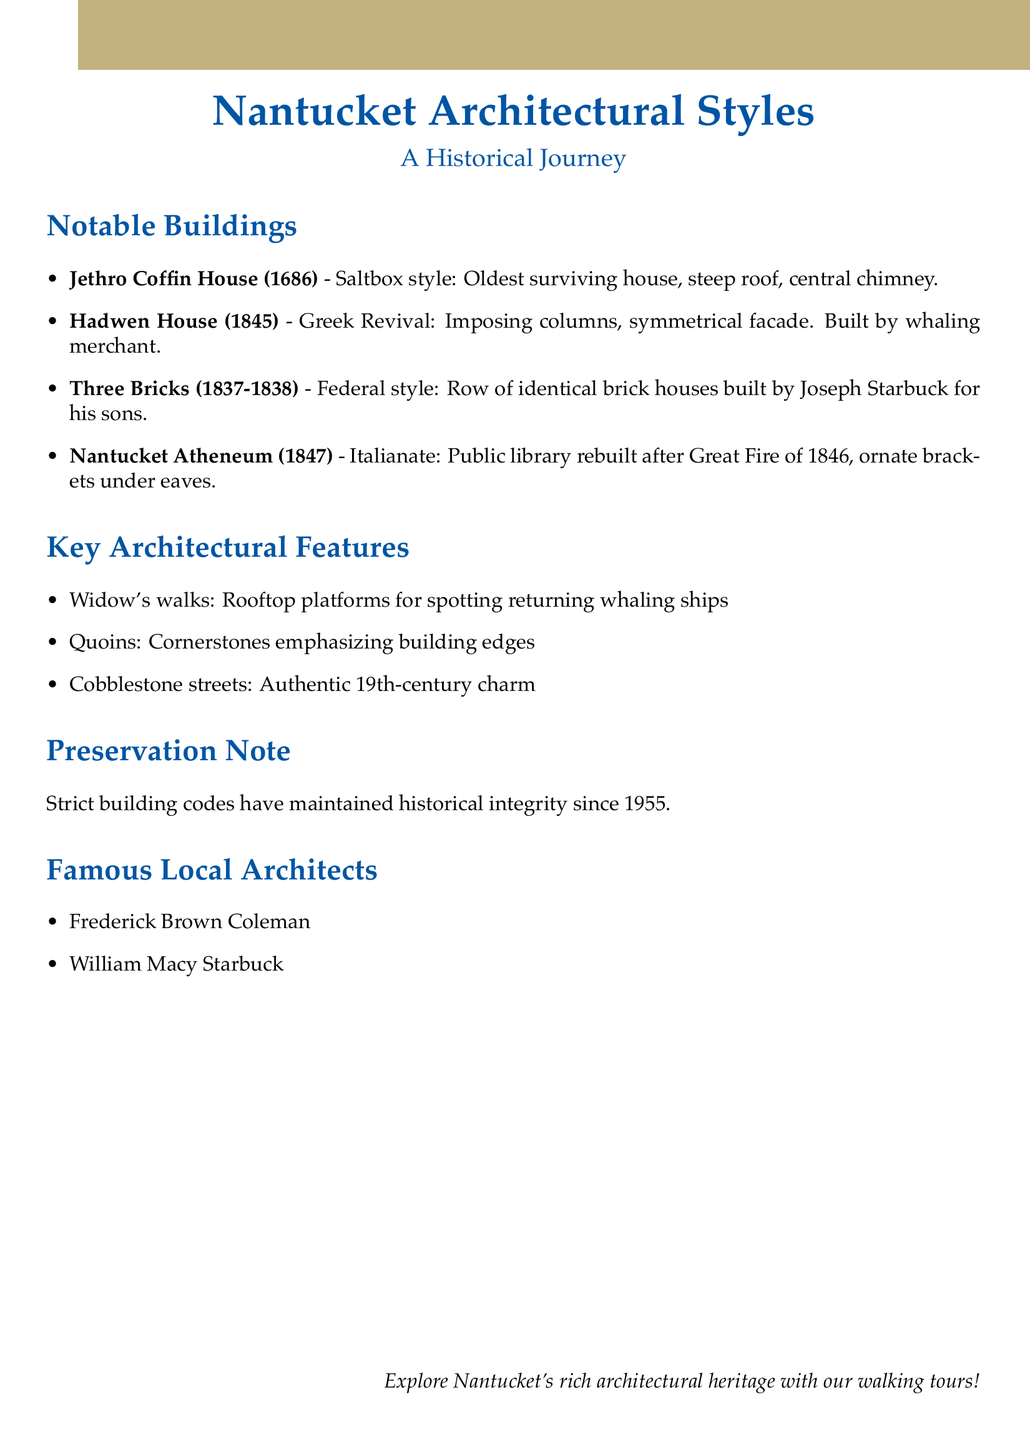What is the oldest surviving house on Nantucket? The document identifies the Jethro Coffin House as the oldest surviving house on Nantucket, built in 1686.
Answer: Jethro Coffin House What architectural style is the Hadwen House? The Hadwen House is described in the document as being of Greek Revival style.
Answer: Greek Revival In which year was the Nantucket Atheneum rebuilt? According to the notes, the Nantucket Atheneum was rebuilt after the Great Fire of 1846, which indicates its rebuilding year as 1847.
Answer: 1847 How many identical houses are in the Three Bricks? The document states that the Three Bricks consists of a row of three identical brick houses.
Answer: Three Who built the Three Bricks? The document includes the information that the Three Bricks was built by Joseph Starbuck for his sons.
Answer: Joseph Starbuck What is a key architectural feature that signifies building edges? The document lists quoins as the architectural feature that emphasizes building edges.
Answer: Quoins What preservation measure has been in place since 1955? The document notes that strict building codes have been maintained since 1955 to preserve historical integrity.
Answer: Strict building codes Who are two famous local architects mentioned in the document? The document lists Frederick Brown Coleman and William Macy Starbuck as famous local architects.
Answer: Frederick Brown Coleman, William Macy Starbuck 